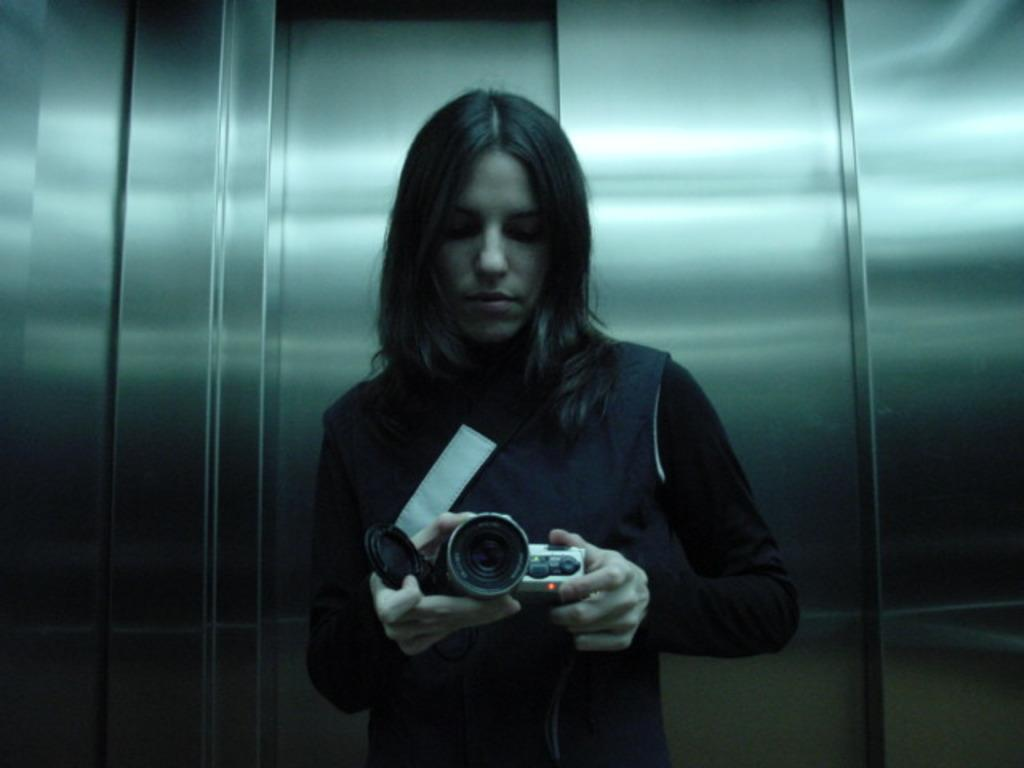What is the main subject of the image? The main subject of the image is a woman. Where is the woman located in the image? The woman is standing in a lift. What is the woman holding in the image? The woman is holding a camera. Are the woman and her sister having an argument in the image? There is no mention of a sister or any argument in the image; it only features a woman holding a camera in a lift. 